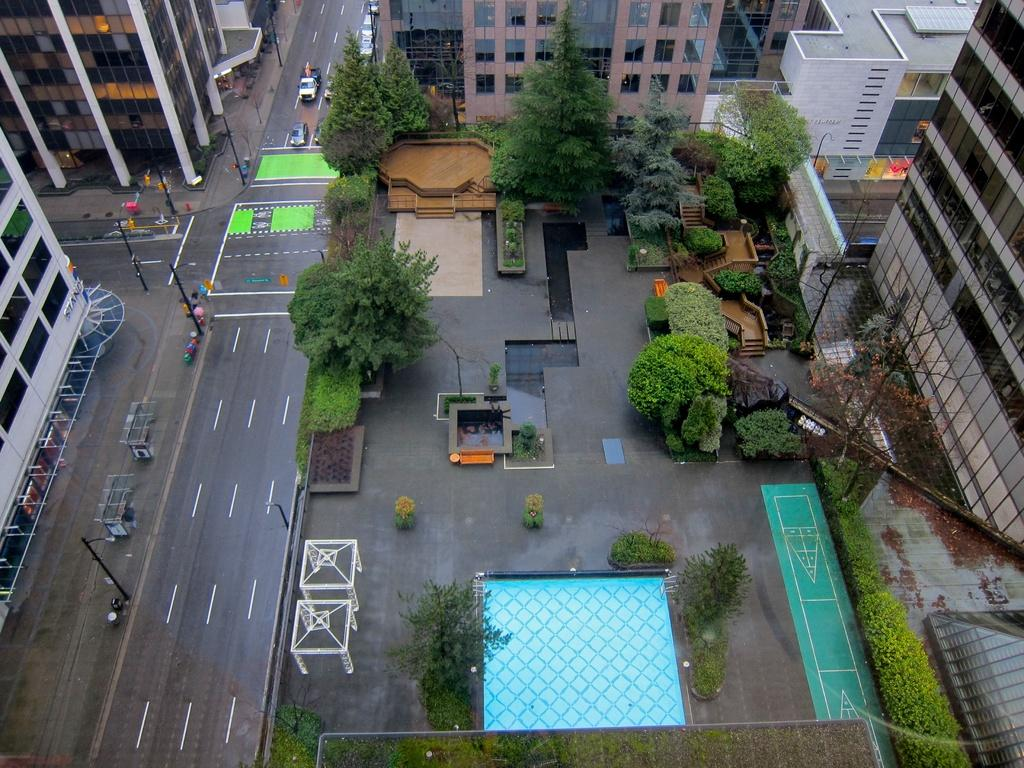What can be seen on the road in the image? There are many vehicles on the road in the image. What type of vegetation is present in the image? There are trees and plants in green color in the image. What colors are the buildings in the image? The buildings in the image are in white, brown, and cream color. What structures can be seen supporting electrical wires in the image? There are electric poles visible in the image. What type of plants can be seen in the downtown area of the image? The provided facts do not mention a downtown area or any specific type of plants in the image. 